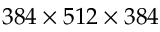<formula> <loc_0><loc_0><loc_500><loc_500>3 8 4 \times 5 1 2 \times 3 8 4</formula> 